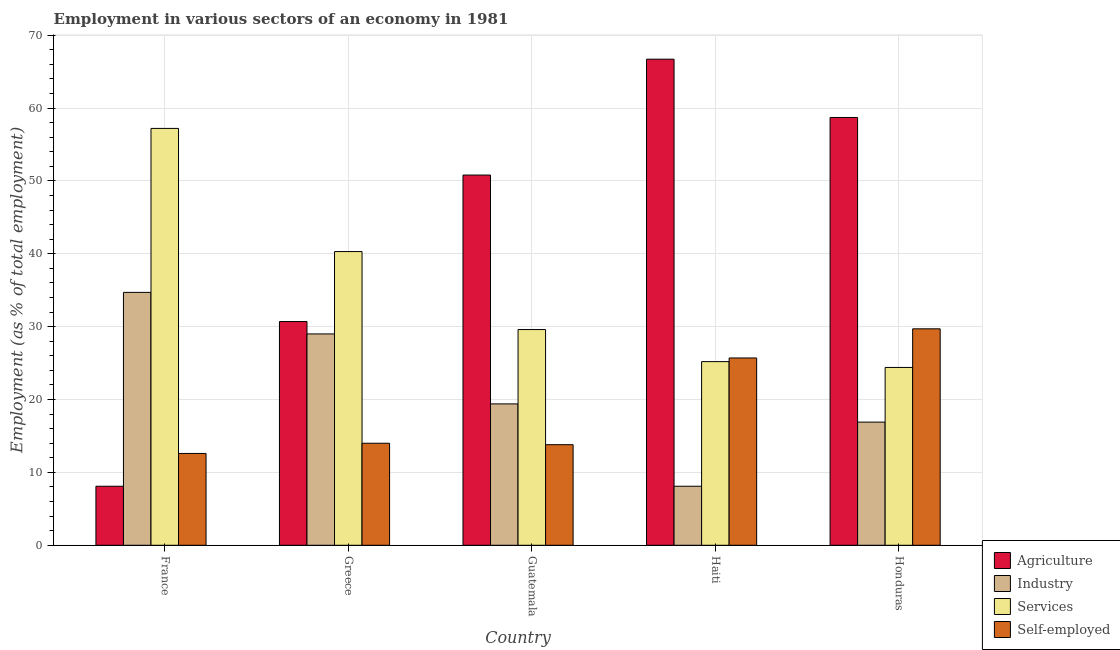Are the number of bars per tick equal to the number of legend labels?
Offer a terse response. Yes. In how many cases, is the number of bars for a given country not equal to the number of legend labels?
Make the answer very short. 0. What is the percentage of workers in industry in Guatemala?
Keep it short and to the point. 19.4. Across all countries, what is the maximum percentage of self employed workers?
Provide a short and direct response. 29.7. Across all countries, what is the minimum percentage of workers in agriculture?
Ensure brevity in your answer.  8.1. In which country was the percentage of workers in industry minimum?
Ensure brevity in your answer.  Haiti. What is the total percentage of workers in industry in the graph?
Keep it short and to the point. 108.1. What is the difference between the percentage of self employed workers in France and that in Haiti?
Your response must be concise. -13.1. What is the difference between the percentage of workers in industry in Guatemala and the percentage of self employed workers in Greece?
Make the answer very short. 5.4. What is the average percentage of workers in industry per country?
Offer a terse response. 21.62. What is the ratio of the percentage of self employed workers in France to that in Greece?
Offer a terse response. 0.9. What is the difference between the highest and the second highest percentage of workers in agriculture?
Keep it short and to the point. 8. What is the difference between the highest and the lowest percentage of workers in industry?
Your answer should be compact. 26.6. Is the sum of the percentage of workers in services in Greece and Haiti greater than the maximum percentage of self employed workers across all countries?
Your answer should be very brief. Yes. Is it the case that in every country, the sum of the percentage of workers in agriculture and percentage of workers in industry is greater than the sum of percentage of self employed workers and percentage of workers in services?
Offer a very short reply. No. What does the 1st bar from the left in Honduras represents?
Your answer should be very brief. Agriculture. What does the 4th bar from the right in France represents?
Provide a succinct answer. Agriculture. How many bars are there?
Offer a terse response. 20. How many countries are there in the graph?
Keep it short and to the point. 5. Does the graph contain grids?
Offer a terse response. Yes. Where does the legend appear in the graph?
Ensure brevity in your answer.  Bottom right. What is the title of the graph?
Provide a succinct answer. Employment in various sectors of an economy in 1981. Does "Primary" appear as one of the legend labels in the graph?
Make the answer very short. No. What is the label or title of the Y-axis?
Offer a terse response. Employment (as % of total employment). What is the Employment (as % of total employment) in Agriculture in France?
Provide a succinct answer. 8.1. What is the Employment (as % of total employment) in Industry in France?
Ensure brevity in your answer.  34.7. What is the Employment (as % of total employment) of Services in France?
Provide a short and direct response. 57.2. What is the Employment (as % of total employment) in Self-employed in France?
Provide a short and direct response. 12.6. What is the Employment (as % of total employment) in Agriculture in Greece?
Give a very brief answer. 30.7. What is the Employment (as % of total employment) in Industry in Greece?
Keep it short and to the point. 29. What is the Employment (as % of total employment) in Services in Greece?
Offer a terse response. 40.3. What is the Employment (as % of total employment) in Self-employed in Greece?
Make the answer very short. 14. What is the Employment (as % of total employment) of Agriculture in Guatemala?
Your answer should be very brief. 50.8. What is the Employment (as % of total employment) of Industry in Guatemala?
Your answer should be very brief. 19.4. What is the Employment (as % of total employment) of Services in Guatemala?
Ensure brevity in your answer.  29.6. What is the Employment (as % of total employment) in Self-employed in Guatemala?
Make the answer very short. 13.8. What is the Employment (as % of total employment) in Agriculture in Haiti?
Provide a succinct answer. 66.7. What is the Employment (as % of total employment) of Industry in Haiti?
Offer a very short reply. 8.1. What is the Employment (as % of total employment) of Services in Haiti?
Offer a terse response. 25.2. What is the Employment (as % of total employment) of Self-employed in Haiti?
Keep it short and to the point. 25.7. What is the Employment (as % of total employment) in Agriculture in Honduras?
Your answer should be compact. 58.7. What is the Employment (as % of total employment) in Industry in Honduras?
Offer a very short reply. 16.9. What is the Employment (as % of total employment) of Services in Honduras?
Keep it short and to the point. 24.4. What is the Employment (as % of total employment) of Self-employed in Honduras?
Make the answer very short. 29.7. Across all countries, what is the maximum Employment (as % of total employment) in Agriculture?
Your response must be concise. 66.7. Across all countries, what is the maximum Employment (as % of total employment) in Industry?
Provide a succinct answer. 34.7. Across all countries, what is the maximum Employment (as % of total employment) in Services?
Offer a terse response. 57.2. Across all countries, what is the maximum Employment (as % of total employment) in Self-employed?
Ensure brevity in your answer.  29.7. Across all countries, what is the minimum Employment (as % of total employment) of Agriculture?
Your answer should be compact. 8.1. Across all countries, what is the minimum Employment (as % of total employment) in Industry?
Ensure brevity in your answer.  8.1. Across all countries, what is the minimum Employment (as % of total employment) of Services?
Offer a very short reply. 24.4. Across all countries, what is the minimum Employment (as % of total employment) of Self-employed?
Give a very brief answer. 12.6. What is the total Employment (as % of total employment) of Agriculture in the graph?
Your response must be concise. 215. What is the total Employment (as % of total employment) in Industry in the graph?
Provide a short and direct response. 108.1. What is the total Employment (as % of total employment) in Services in the graph?
Your answer should be very brief. 176.7. What is the total Employment (as % of total employment) in Self-employed in the graph?
Offer a terse response. 95.8. What is the difference between the Employment (as % of total employment) in Agriculture in France and that in Greece?
Provide a short and direct response. -22.6. What is the difference between the Employment (as % of total employment) in Services in France and that in Greece?
Provide a short and direct response. 16.9. What is the difference between the Employment (as % of total employment) in Self-employed in France and that in Greece?
Make the answer very short. -1.4. What is the difference between the Employment (as % of total employment) of Agriculture in France and that in Guatemala?
Provide a short and direct response. -42.7. What is the difference between the Employment (as % of total employment) of Industry in France and that in Guatemala?
Make the answer very short. 15.3. What is the difference between the Employment (as % of total employment) of Services in France and that in Guatemala?
Provide a succinct answer. 27.6. What is the difference between the Employment (as % of total employment) of Agriculture in France and that in Haiti?
Your answer should be compact. -58.6. What is the difference between the Employment (as % of total employment) in Industry in France and that in Haiti?
Ensure brevity in your answer.  26.6. What is the difference between the Employment (as % of total employment) of Services in France and that in Haiti?
Offer a terse response. 32. What is the difference between the Employment (as % of total employment) of Agriculture in France and that in Honduras?
Provide a succinct answer. -50.6. What is the difference between the Employment (as % of total employment) in Industry in France and that in Honduras?
Provide a succinct answer. 17.8. What is the difference between the Employment (as % of total employment) of Services in France and that in Honduras?
Make the answer very short. 32.8. What is the difference between the Employment (as % of total employment) of Self-employed in France and that in Honduras?
Your answer should be very brief. -17.1. What is the difference between the Employment (as % of total employment) of Agriculture in Greece and that in Guatemala?
Keep it short and to the point. -20.1. What is the difference between the Employment (as % of total employment) of Agriculture in Greece and that in Haiti?
Provide a short and direct response. -36. What is the difference between the Employment (as % of total employment) in Industry in Greece and that in Haiti?
Offer a very short reply. 20.9. What is the difference between the Employment (as % of total employment) in Agriculture in Greece and that in Honduras?
Your answer should be compact. -28. What is the difference between the Employment (as % of total employment) in Self-employed in Greece and that in Honduras?
Your answer should be very brief. -15.7. What is the difference between the Employment (as % of total employment) in Agriculture in Guatemala and that in Haiti?
Provide a succinct answer. -15.9. What is the difference between the Employment (as % of total employment) of Industry in Guatemala and that in Haiti?
Keep it short and to the point. 11.3. What is the difference between the Employment (as % of total employment) in Self-employed in Guatemala and that in Haiti?
Ensure brevity in your answer.  -11.9. What is the difference between the Employment (as % of total employment) of Services in Guatemala and that in Honduras?
Keep it short and to the point. 5.2. What is the difference between the Employment (as % of total employment) in Self-employed in Guatemala and that in Honduras?
Make the answer very short. -15.9. What is the difference between the Employment (as % of total employment) in Industry in Haiti and that in Honduras?
Ensure brevity in your answer.  -8.8. What is the difference between the Employment (as % of total employment) in Self-employed in Haiti and that in Honduras?
Offer a very short reply. -4. What is the difference between the Employment (as % of total employment) in Agriculture in France and the Employment (as % of total employment) in Industry in Greece?
Make the answer very short. -20.9. What is the difference between the Employment (as % of total employment) in Agriculture in France and the Employment (as % of total employment) in Services in Greece?
Your answer should be very brief. -32.2. What is the difference between the Employment (as % of total employment) in Industry in France and the Employment (as % of total employment) in Services in Greece?
Make the answer very short. -5.6. What is the difference between the Employment (as % of total employment) of Industry in France and the Employment (as % of total employment) of Self-employed in Greece?
Provide a succinct answer. 20.7. What is the difference between the Employment (as % of total employment) of Services in France and the Employment (as % of total employment) of Self-employed in Greece?
Offer a very short reply. 43.2. What is the difference between the Employment (as % of total employment) in Agriculture in France and the Employment (as % of total employment) in Services in Guatemala?
Offer a terse response. -21.5. What is the difference between the Employment (as % of total employment) of Agriculture in France and the Employment (as % of total employment) of Self-employed in Guatemala?
Your answer should be compact. -5.7. What is the difference between the Employment (as % of total employment) in Industry in France and the Employment (as % of total employment) in Services in Guatemala?
Your answer should be very brief. 5.1. What is the difference between the Employment (as % of total employment) of Industry in France and the Employment (as % of total employment) of Self-employed in Guatemala?
Provide a short and direct response. 20.9. What is the difference between the Employment (as % of total employment) in Services in France and the Employment (as % of total employment) in Self-employed in Guatemala?
Your answer should be compact. 43.4. What is the difference between the Employment (as % of total employment) in Agriculture in France and the Employment (as % of total employment) in Industry in Haiti?
Provide a short and direct response. 0. What is the difference between the Employment (as % of total employment) of Agriculture in France and the Employment (as % of total employment) of Services in Haiti?
Give a very brief answer. -17.1. What is the difference between the Employment (as % of total employment) of Agriculture in France and the Employment (as % of total employment) of Self-employed in Haiti?
Ensure brevity in your answer.  -17.6. What is the difference between the Employment (as % of total employment) in Industry in France and the Employment (as % of total employment) in Self-employed in Haiti?
Your answer should be very brief. 9. What is the difference between the Employment (as % of total employment) in Services in France and the Employment (as % of total employment) in Self-employed in Haiti?
Provide a succinct answer. 31.5. What is the difference between the Employment (as % of total employment) in Agriculture in France and the Employment (as % of total employment) in Industry in Honduras?
Provide a short and direct response. -8.8. What is the difference between the Employment (as % of total employment) of Agriculture in France and the Employment (as % of total employment) of Services in Honduras?
Your answer should be compact. -16.3. What is the difference between the Employment (as % of total employment) of Agriculture in France and the Employment (as % of total employment) of Self-employed in Honduras?
Provide a short and direct response. -21.6. What is the difference between the Employment (as % of total employment) in Industry in France and the Employment (as % of total employment) in Self-employed in Honduras?
Give a very brief answer. 5. What is the difference between the Employment (as % of total employment) of Services in France and the Employment (as % of total employment) of Self-employed in Honduras?
Your response must be concise. 27.5. What is the difference between the Employment (as % of total employment) in Agriculture in Greece and the Employment (as % of total employment) in Services in Guatemala?
Offer a very short reply. 1.1. What is the difference between the Employment (as % of total employment) in Agriculture in Greece and the Employment (as % of total employment) in Self-employed in Guatemala?
Ensure brevity in your answer.  16.9. What is the difference between the Employment (as % of total employment) of Industry in Greece and the Employment (as % of total employment) of Self-employed in Guatemala?
Offer a very short reply. 15.2. What is the difference between the Employment (as % of total employment) in Services in Greece and the Employment (as % of total employment) in Self-employed in Guatemala?
Your answer should be very brief. 26.5. What is the difference between the Employment (as % of total employment) of Agriculture in Greece and the Employment (as % of total employment) of Industry in Haiti?
Keep it short and to the point. 22.6. What is the difference between the Employment (as % of total employment) in Industry in Greece and the Employment (as % of total employment) in Services in Haiti?
Offer a terse response. 3.8. What is the difference between the Employment (as % of total employment) of Industry in Greece and the Employment (as % of total employment) of Self-employed in Haiti?
Your answer should be very brief. 3.3. What is the difference between the Employment (as % of total employment) in Services in Greece and the Employment (as % of total employment) in Self-employed in Haiti?
Give a very brief answer. 14.6. What is the difference between the Employment (as % of total employment) of Agriculture in Greece and the Employment (as % of total employment) of Industry in Honduras?
Provide a succinct answer. 13.8. What is the difference between the Employment (as % of total employment) in Agriculture in Guatemala and the Employment (as % of total employment) in Industry in Haiti?
Provide a succinct answer. 42.7. What is the difference between the Employment (as % of total employment) of Agriculture in Guatemala and the Employment (as % of total employment) of Services in Haiti?
Offer a terse response. 25.6. What is the difference between the Employment (as % of total employment) in Agriculture in Guatemala and the Employment (as % of total employment) in Self-employed in Haiti?
Your response must be concise. 25.1. What is the difference between the Employment (as % of total employment) of Agriculture in Guatemala and the Employment (as % of total employment) of Industry in Honduras?
Keep it short and to the point. 33.9. What is the difference between the Employment (as % of total employment) in Agriculture in Guatemala and the Employment (as % of total employment) in Services in Honduras?
Your answer should be very brief. 26.4. What is the difference between the Employment (as % of total employment) of Agriculture in Guatemala and the Employment (as % of total employment) of Self-employed in Honduras?
Ensure brevity in your answer.  21.1. What is the difference between the Employment (as % of total employment) in Industry in Guatemala and the Employment (as % of total employment) in Services in Honduras?
Ensure brevity in your answer.  -5. What is the difference between the Employment (as % of total employment) of Services in Guatemala and the Employment (as % of total employment) of Self-employed in Honduras?
Ensure brevity in your answer.  -0.1. What is the difference between the Employment (as % of total employment) of Agriculture in Haiti and the Employment (as % of total employment) of Industry in Honduras?
Offer a very short reply. 49.8. What is the difference between the Employment (as % of total employment) of Agriculture in Haiti and the Employment (as % of total employment) of Services in Honduras?
Your answer should be compact. 42.3. What is the difference between the Employment (as % of total employment) of Industry in Haiti and the Employment (as % of total employment) of Services in Honduras?
Make the answer very short. -16.3. What is the difference between the Employment (as % of total employment) in Industry in Haiti and the Employment (as % of total employment) in Self-employed in Honduras?
Keep it short and to the point. -21.6. What is the difference between the Employment (as % of total employment) in Services in Haiti and the Employment (as % of total employment) in Self-employed in Honduras?
Make the answer very short. -4.5. What is the average Employment (as % of total employment) of Industry per country?
Give a very brief answer. 21.62. What is the average Employment (as % of total employment) of Services per country?
Ensure brevity in your answer.  35.34. What is the average Employment (as % of total employment) in Self-employed per country?
Offer a terse response. 19.16. What is the difference between the Employment (as % of total employment) in Agriculture and Employment (as % of total employment) in Industry in France?
Give a very brief answer. -26.6. What is the difference between the Employment (as % of total employment) of Agriculture and Employment (as % of total employment) of Services in France?
Your answer should be compact. -49.1. What is the difference between the Employment (as % of total employment) of Industry and Employment (as % of total employment) of Services in France?
Provide a short and direct response. -22.5. What is the difference between the Employment (as % of total employment) of Industry and Employment (as % of total employment) of Self-employed in France?
Ensure brevity in your answer.  22.1. What is the difference between the Employment (as % of total employment) in Services and Employment (as % of total employment) in Self-employed in France?
Offer a very short reply. 44.6. What is the difference between the Employment (as % of total employment) in Agriculture and Employment (as % of total employment) in Industry in Greece?
Keep it short and to the point. 1.7. What is the difference between the Employment (as % of total employment) of Agriculture and Employment (as % of total employment) of Self-employed in Greece?
Your answer should be very brief. 16.7. What is the difference between the Employment (as % of total employment) of Industry and Employment (as % of total employment) of Services in Greece?
Your response must be concise. -11.3. What is the difference between the Employment (as % of total employment) of Industry and Employment (as % of total employment) of Self-employed in Greece?
Offer a very short reply. 15. What is the difference between the Employment (as % of total employment) of Services and Employment (as % of total employment) of Self-employed in Greece?
Offer a terse response. 26.3. What is the difference between the Employment (as % of total employment) of Agriculture and Employment (as % of total employment) of Industry in Guatemala?
Give a very brief answer. 31.4. What is the difference between the Employment (as % of total employment) in Agriculture and Employment (as % of total employment) in Services in Guatemala?
Your answer should be very brief. 21.2. What is the difference between the Employment (as % of total employment) in Industry and Employment (as % of total employment) in Services in Guatemala?
Your answer should be very brief. -10.2. What is the difference between the Employment (as % of total employment) in Agriculture and Employment (as % of total employment) in Industry in Haiti?
Make the answer very short. 58.6. What is the difference between the Employment (as % of total employment) of Agriculture and Employment (as % of total employment) of Services in Haiti?
Make the answer very short. 41.5. What is the difference between the Employment (as % of total employment) in Industry and Employment (as % of total employment) in Services in Haiti?
Offer a terse response. -17.1. What is the difference between the Employment (as % of total employment) in Industry and Employment (as % of total employment) in Self-employed in Haiti?
Make the answer very short. -17.6. What is the difference between the Employment (as % of total employment) of Agriculture and Employment (as % of total employment) of Industry in Honduras?
Your answer should be compact. 41.8. What is the difference between the Employment (as % of total employment) of Agriculture and Employment (as % of total employment) of Services in Honduras?
Provide a short and direct response. 34.3. What is the difference between the Employment (as % of total employment) in Agriculture and Employment (as % of total employment) in Self-employed in Honduras?
Make the answer very short. 29. What is the difference between the Employment (as % of total employment) of Industry and Employment (as % of total employment) of Services in Honduras?
Keep it short and to the point. -7.5. What is the difference between the Employment (as % of total employment) in Industry and Employment (as % of total employment) in Self-employed in Honduras?
Your answer should be very brief. -12.8. What is the difference between the Employment (as % of total employment) in Services and Employment (as % of total employment) in Self-employed in Honduras?
Offer a very short reply. -5.3. What is the ratio of the Employment (as % of total employment) of Agriculture in France to that in Greece?
Ensure brevity in your answer.  0.26. What is the ratio of the Employment (as % of total employment) in Industry in France to that in Greece?
Offer a very short reply. 1.2. What is the ratio of the Employment (as % of total employment) of Services in France to that in Greece?
Keep it short and to the point. 1.42. What is the ratio of the Employment (as % of total employment) in Agriculture in France to that in Guatemala?
Offer a terse response. 0.16. What is the ratio of the Employment (as % of total employment) in Industry in France to that in Guatemala?
Make the answer very short. 1.79. What is the ratio of the Employment (as % of total employment) of Services in France to that in Guatemala?
Give a very brief answer. 1.93. What is the ratio of the Employment (as % of total employment) of Self-employed in France to that in Guatemala?
Provide a short and direct response. 0.91. What is the ratio of the Employment (as % of total employment) of Agriculture in France to that in Haiti?
Provide a short and direct response. 0.12. What is the ratio of the Employment (as % of total employment) of Industry in France to that in Haiti?
Provide a short and direct response. 4.28. What is the ratio of the Employment (as % of total employment) of Services in France to that in Haiti?
Give a very brief answer. 2.27. What is the ratio of the Employment (as % of total employment) in Self-employed in France to that in Haiti?
Provide a short and direct response. 0.49. What is the ratio of the Employment (as % of total employment) in Agriculture in France to that in Honduras?
Ensure brevity in your answer.  0.14. What is the ratio of the Employment (as % of total employment) in Industry in France to that in Honduras?
Offer a terse response. 2.05. What is the ratio of the Employment (as % of total employment) in Services in France to that in Honduras?
Give a very brief answer. 2.34. What is the ratio of the Employment (as % of total employment) in Self-employed in France to that in Honduras?
Your answer should be very brief. 0.42. What is the ratio of the Employment (as % of total employment) of Agriculture in Greece to that in Guatemala?
Ensure brevity in your answer.  0.6. What is the ratio of the Employment (as % of total employment) in Industry in Greece to that in Guatemala?
Keep it short and to the point. 1.49. What is the ratio of the Employment (as % of total employment) in Services in Greece to that in Guatemala?
Ensure brevity in your answer.  1.36. What is the ratio of the Employment (as % of total employment) of Self-employed in Greece to that in Guatemala?
Your answer should be very brief. 1.01. What is the ratio of the Employment (as % of total employment) in Agriculture in Greece to that in Haiti?
Your answer should be very brief. 0.46. What is the ratio of the Employment (as % of total employment) in Industry in Greece to that in Haiti?
Offer a terse response. 3.58. What is the ratio of the Employment (as % of total employment) of Services in Greece to that in Haiti?
Offer a very short reply. 1.6. What is the ratio of the Employment (as % of total employment) of Self-employed in Greece to that in Haiti?
Provide a succinct answer. 0.54. What is the ratio of the Employment (as % of total employment) of Agriculture in Greece to that in Honduras?
Keep it short and to the point. 0.52. What is the ratio of the Employment (as % of total employment) in Industry in Greece to that in Honduras?
Ensure brevity in your answer.  1.72. What is the ratio of the Employment (as % of total employment) of Services in Greece to that in Honduras?
Your answer should be compact. 1.65. What is the ratio of the Employment (as % of total employment) of Self-employed in Greece to that in Honduras?
Make the answer very short. 0.47. What is the ratio of the Employment (as % of total employment) in Agriculture in Guatemala to that in Haiti?
Offer a very short reply. 0.76. What is the ratio of the Employment (as % of total employment) in Industry in Guatemala to that in Haiti?
Your response must be concise. 2.4. What is the ratio of the Employment (as % of total employment) of Services in Guatemala to that in Haiti?
Offer a terse response. 1.17. What is the ratio of the Employment (as % of total employment) in Self-employed in Guatemala to that in Haiti?
Give a very brief answer. 0.54. What is the ratio of the Employment (as % of total employment) in Agriculture in Guatemala to that in Honduras?
Make the answer very short. 0.87. What is the ratio of the Employment (as % of total employment) of Industry in Guatemala to that in Honduras?
Offer a terse response. 1.15. What is the ratio of the Employment (as % of total employment) of Services in Guatemala to that in Honduras?
Give a very brief answer. 1.21. What is the ratio of the Employment (as % of total employment) in Self-employed in Guatemala to that in Honduras?
Your answer should be very brief. 0.46. What is the ratio of the Employment (as % of total employment) of Agriculture in Haiti to that in Honduras?
Provide a short and direct response. 1.14. What is the ratio of the Employment (as % of total employment) in Industry in Haiti to that in Honduras?
Make the answer very short. 0.48. What is the ratio of the Employment (as % of total employment) of Services in Haiti to that in Honduras?
Offer a terse response. 1.03. What is the ratio of the Employment (as % of total employment) in Self-employed in Haiti to that in Honduras?
Your answer should be compact. 0.87. What is the difference between the highest and the second highest Employment (as % of total employment) of Industry?
Provide a succinct answer. 5.7. What is the difference between the highest and the lowest Employment (as % of total employment) of Agriculture?
Offer a terse response. 58.6. What is the difference between the highest and the lowest Employment (as % of total employment) of Industry?
Provide a succinct answer. 26.6. What is the difference between the highest and the lowest Employment (as % of total employment) of Services?
Your answer should be very brief. 32.8. What is the difference between the highest and the lowest Employment (as % of total employment) of Self-employed?
Keep it short and to the point. 17.1. 